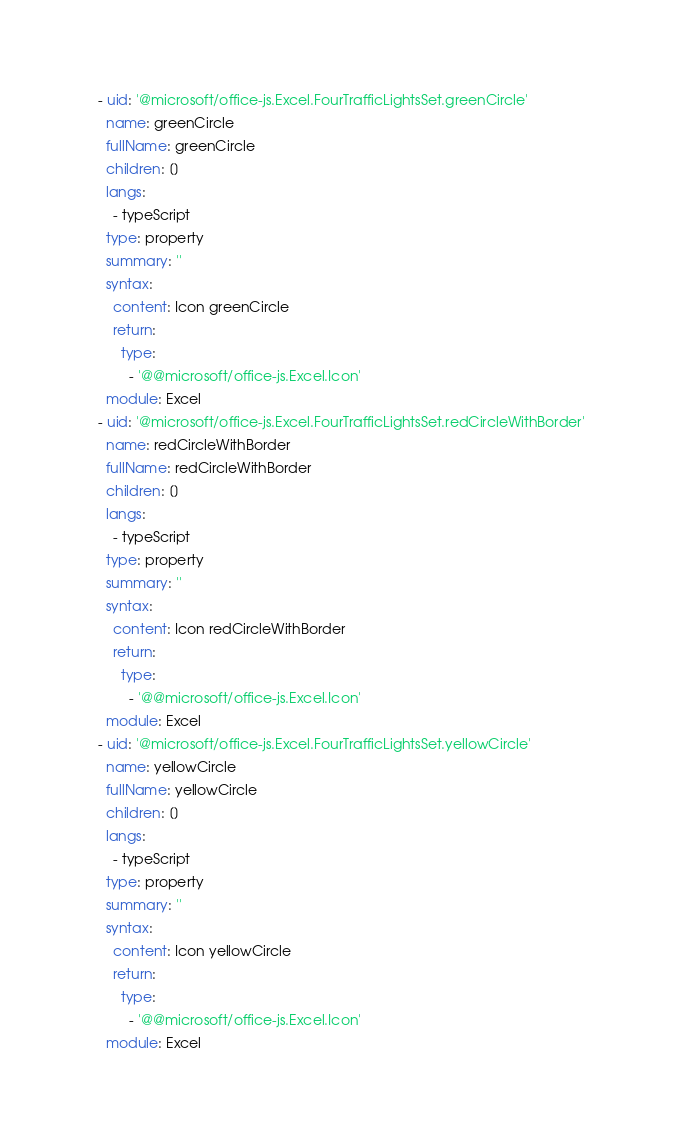Convert code to text. <code><loc_0><loc_0><loc_500><loc_500><_YAML_>  - uid: '@microsoft/office-js.Excel.FourTrafficLightsSet.greenCircle'
    name: greenCircle
    fullName: greenCircle
    children: []
    langs:
      - typeScript
    type: property
    summary: ''
    syntax:
      content: Icon greenCircle
      return:
        type:
          - '@@microsoft/office-js.Excel.Icon'
    module: Excel
  - uid: '@microsoft/office-js.Excel.FourTrafficLightsSet.redCircleWithBorder'
    name: redCircleWithBorder
    fullName: redCircleWithBorder
    children: []
    langs:
      - typeScript
    type: property
    summary: ''
    syntax:
      content: Icon redCircleWithBorder
      return:
        type:
          - '@@microsoft/office-js.Excel.Icon'
    module: Excel
  - uid: '@microsoft/office-js.Excel.FourTrafficLightsSet.yellowCircle'
    name: yellowCircle
    fullName: yellowCircle
    children: []
    langs:
      - typeScript
    type: property
    summary: ''
    syntax:
      content: Icon yellowCircle
      return:
        type:
          - '@@microsoft/office-js.Excel.Icon'
    module: Excel
</code> 